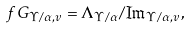<formula> <loc_0><loc_0><loc_500><loc_500>\ f G _ { \Upsilon / \alpha , v } = \Lambda _ { \Upsilon / \alpha } / \Im _ { \Upsilon / \alpha , v } ,</formula> 